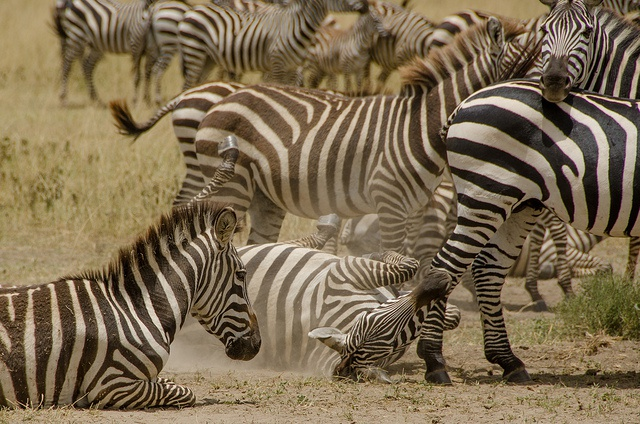Describe the objects in this image and their specific colors. I can see zebra in tan, gray, and black tones, zebra in tan, black, gray, and maroon tones, zebra in tan, black, gray, and olive tones, zebra in tan, gray, and black tones, and zebra in tan, olive, gray, and darkgray tones in this image. 